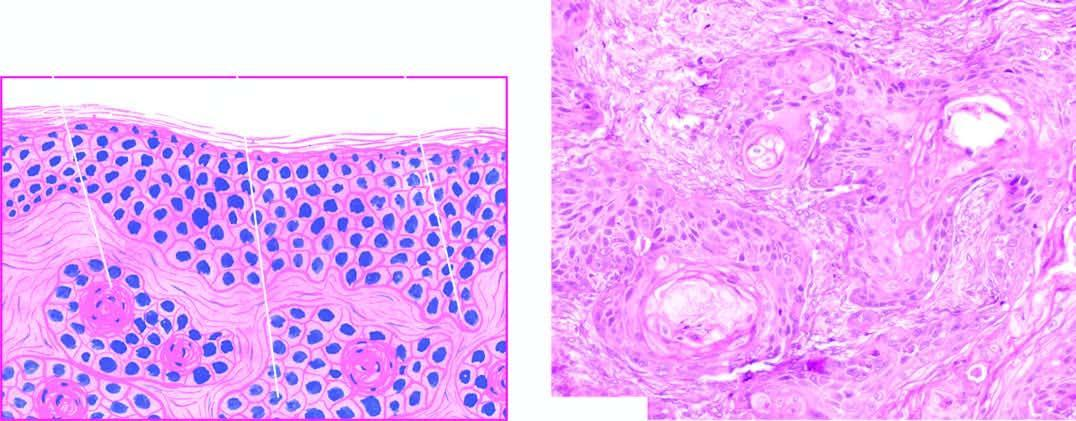what is there in the dermis between the masses of tumour cells?
Answer the question using a single word or phrase. Inflammatory reaction 